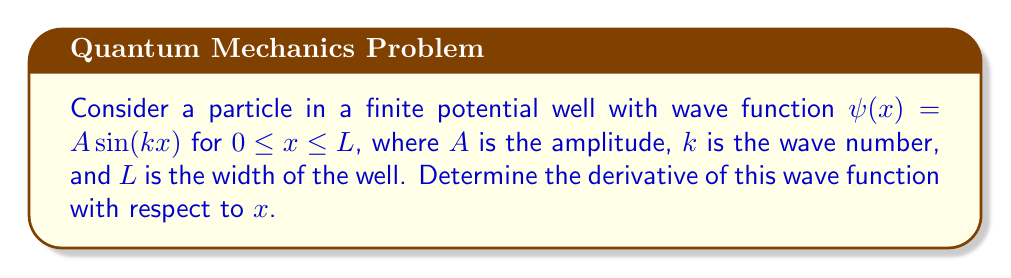Can you answer this question? To find the derivative of the wave function, we'll use the chain rule:

1) The wave function is given by:
   $$\psi(x) = A \sin(kx)$$

2) Let $u = kx$, then $\psi(x) = A \sin(u)$

3) Using the chain rule:
   $$\frac{d\psi}{dx} = \frac{d\psi}{du} \cdot \frac{du}{dx}$$

4) We know that:
   $\frac{d}{du}[\sin(u)] = \cos(u)$
   $\frac{du}{dx} = k$

5) Substituting these into the chain rule:
   $$\frac{d\psi}{dx} = A \cos(u) \cdot k$$

6) Replacing $u$ with $kx$:
   $$\frac{d\psi}{dx} = Ak \cos(kx)$$

This result shows how the wave function changes with position, which is crucial in understanding the behavior of quantum particles in finite potential wells, a topic of great interest in quantum electronics.
Answer: $\frac{d\psi}{dx} = Ak \cos(kx)$ 